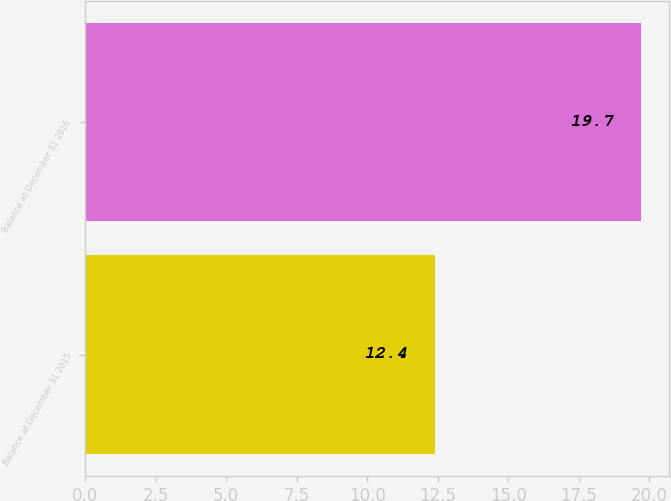<chart> <loc_0><loc_0><loc_500><loc_500><bar_chart><fcel>Balance at December 31 2015<fcel>Balance at December 31 2016<nl><fcel>12.4<fcel>19.7<nl></chart> 